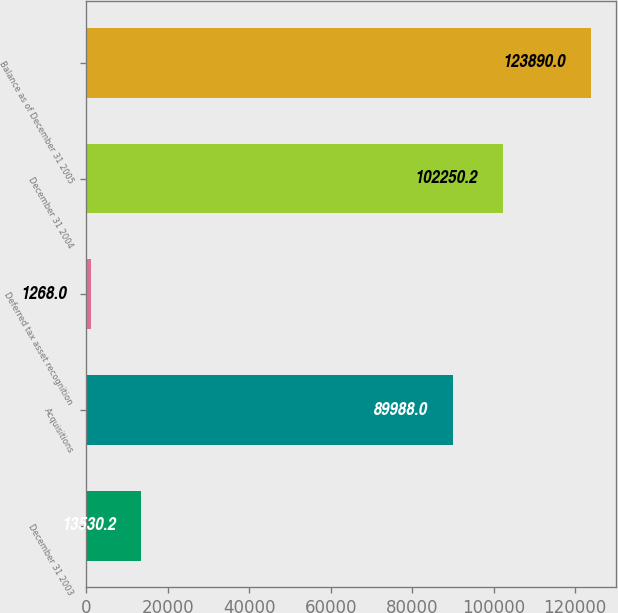<chart> <loc_0><loc_0><loc_500><loc_500><bar_chart><fcel>December 31 2003<fcel>Acquisitions<fcel>Deferred tax asset recognition<fcel>December 31 2004<fcel>Balance as of December 31 2005<nl><fcel>13530.2<fcel>89988<fcel>1268<fcel>102250<fcel>123890<nl></chart> 